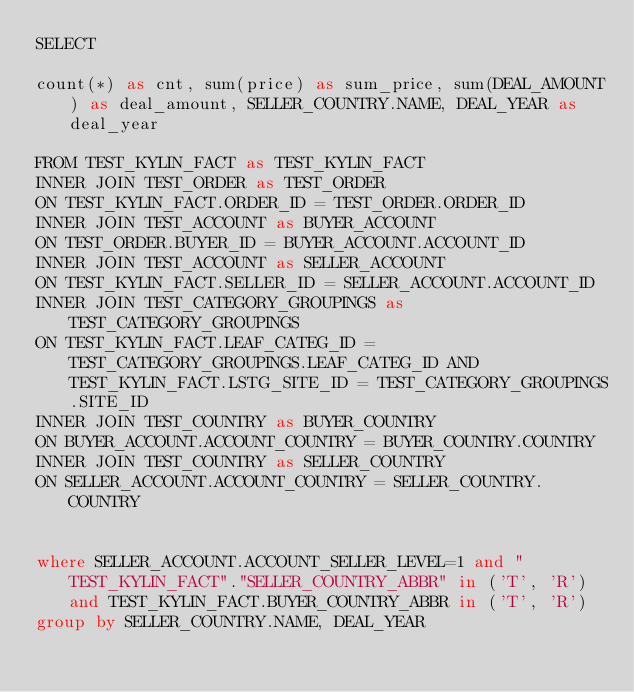<code> <loc_0><loc_0><loc_500><loc_500><_SQL_>SELECT

count(*) as cnt, sum(price) as sum_price, sum(DEAL_AMOUNT) as deal_amount, SELLER_COUNTRY.NAME, DEAL_YEAR as deal_year

FROM TEST_KYLIN_FACT as TEST_KYLIN_FACT 
INNER JOIN TEST_ORDER as TEST_ORDER
ON TEST_KYLIN_FACT.ORDER_ID = TEST_ORDER.ORDER_ID
INNER JOIN TEST_ACCOUNT as BUYER_ACCOUNT
ON TEST_ORDER.BUYER_ID = BUYER_ACCOUNT.ACCOUNT_ID
INNER JOIN TEST_ACCOUNT as SELLER_ACCOUNT
ON TEST_KYLIN_FACT.SELLER_ID = SELLER_ACCOUNT.ACCOUNT_ID
INNER JOIN TEST_CATEGORY_GROUPINGS as TEST_CATEGORY_GROUPINGS
ON TEST_KYLIN_FACT.LEAF_CATEG_ID = TEST_CATEGORY_GROUPINGS.LEAF_CATEG_ID AND TEST_KYLIN_FACT.LSTG_SITE_ID = TEST_CATEGORY_GROUPINGS.SITE_ID
INNER JOIN TEST_COUNTRY as BUYER_COUNTRY
ON BUYER_ACCOUNT.ACCOUNT_COUNTRY = BUYER_COUNTRY.COUNTRY
INNER JOIN TEST_COUNTRY as SELLER_COUNTRY
ON SELLER_ACCOUNT.ACCOUNT_COUNTRY = SELLER_COUNTRY.COUNTRY


where SELLER_ACCOUNT.ACCOUNT_SELLER_LEVEL=1 and "TEST_KYLIN_FACT"."SELLER_COUNTRY_ABBR" in ('T', 'R') and TEST_KYLIN_FACT.BUYER_COUNTRY_ABBR in ('T', 'R')
group by SELLER_COUNTRY.NAME, DEAL_YEAR
</code> 